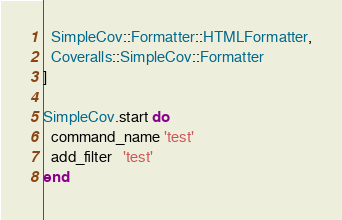Convert code to text. <code><loc_0><loc_0><loc_500><loc_500><_Ruby_>  SimpleCov::Formatter::HTMLFormatter,
  Coveralls::SimpleCov::Formatter
]

SimpleCov.start do
  command_name 'test'
  add_filter   'test'
end
</code> 